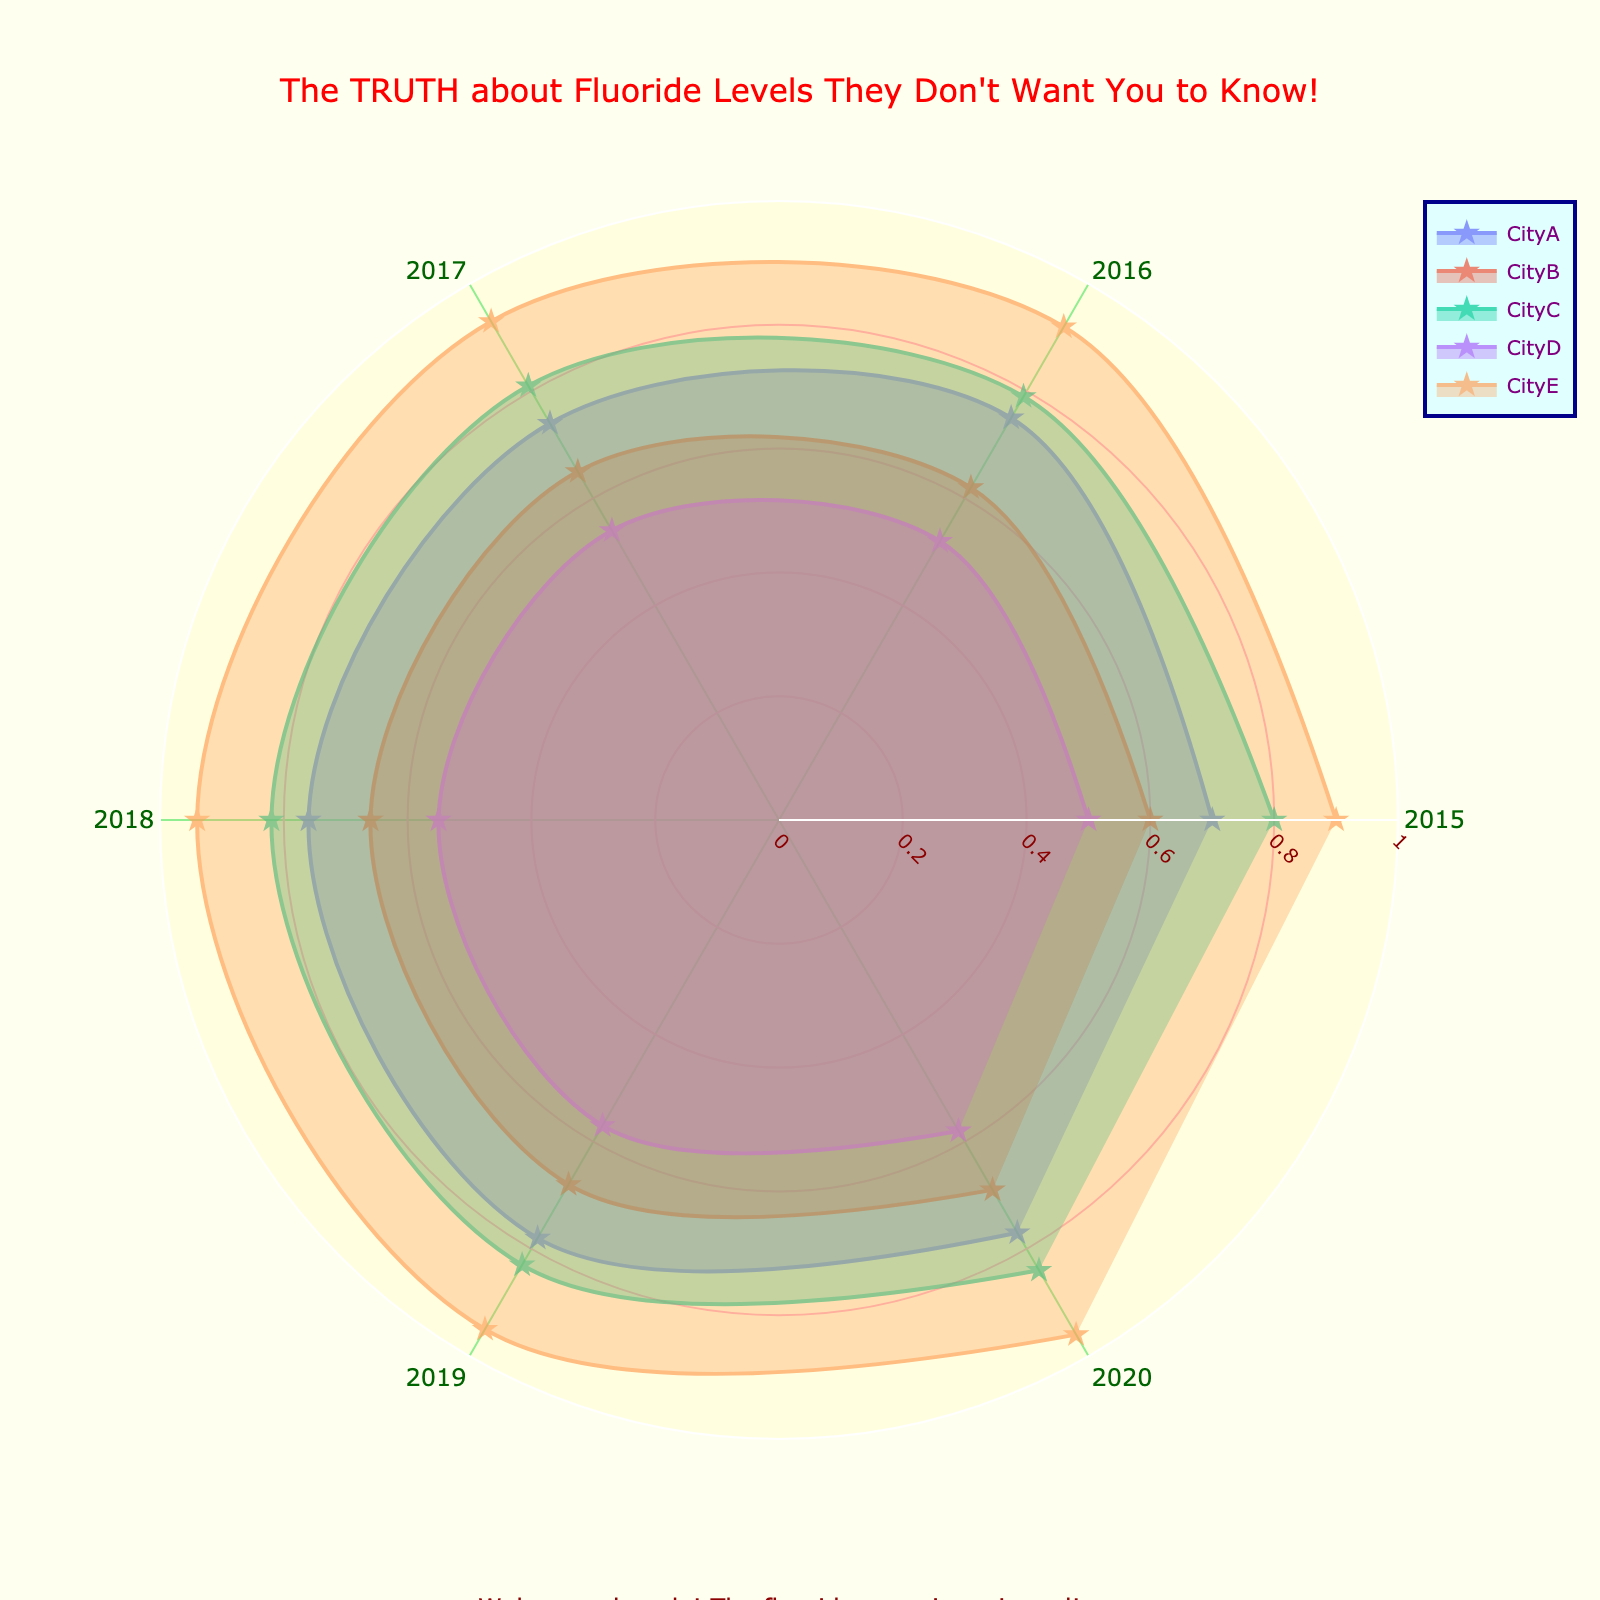what is the title of the chart? The title is usually located at the top of the chart. Here, the title states "The TRUTH about Fluoride Levels They Don't Want You to Know!"
Answer: The TRUTH about Fluoride Levels They Don't Want You to Know! How many cities are represented in the chart? By counting the unique data series, each corresponding to a city, five cities are represented.
Answer: Five What is the highest fluoride level recorded, and in which city? To find the highest fluoride level, identify the highest point on the radial axis in any series. The highest level appears to be 0.96, recorded in CityE in 2020.
Answer: 0.96, CityE Which city has the lowest fluoride levels? To find the lowest fluoride levels, identify the lowest points on the radial axis of all series. The lowest level appears to be 0.5, recorded in CityD in 2015.
Answer: CityD What is the general trend of fluoride levels in CityA? Observing the data points for CityA over the years, there is a slight increase from 0.7 in 2015 to 0.77 in 2020.
Answer: Increasing trend Compare the fluoride levels of CityB in 2015 and CityC in 2015. Which one is higher? Locate the 2015 data points for CityB and CityC on the radial axis. CityB has 0.6, and CityC has 0.8. Thus, CityC has higher fluoride levels.
Answer: CityC Which city has consistently increasing fluoride levels from 2015 to 2020? By examining the slopes for each city's series, CityE shows a consistent increase from 0.9 in 2015 to 0.96 in 2020.
Answer: CityE What is the difference in fluoride levels between CityA and CityB in 2017? Identify the 2017 data points for CityA (0.74) and CityB (0.65) and compute the difference: 0.74 - 0.65 = 0.09.
Answer: 0.09 Do any cities have a decrease in fluoride levels over a consecutive two-year period? Reviewing each city's series over each consecutive period, no visible drops in fluoride levels are observed in any city.
Answer: No Which city shows the smallest variation in fluoride levels over the years? Compare the ranges of fluoride levels for each city; CityC has the smallest range from 0.79 to 0.84, a difference of 0.05.
Answer: CityC 